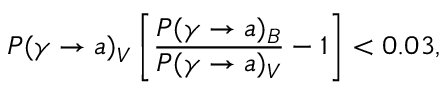Convert formula to latex. <formula><loc_0><loc_0><loc_500><loc_500>P ( \gamma \rightarrow a ) _ { V } \left [ { \frac { P ( \gamma \rightarrow a ) _ { B } } { P ( \gamma \rightarrow a ) _ { V } } } - 1 \right ] < 0 . 0 3 ,</formula> 